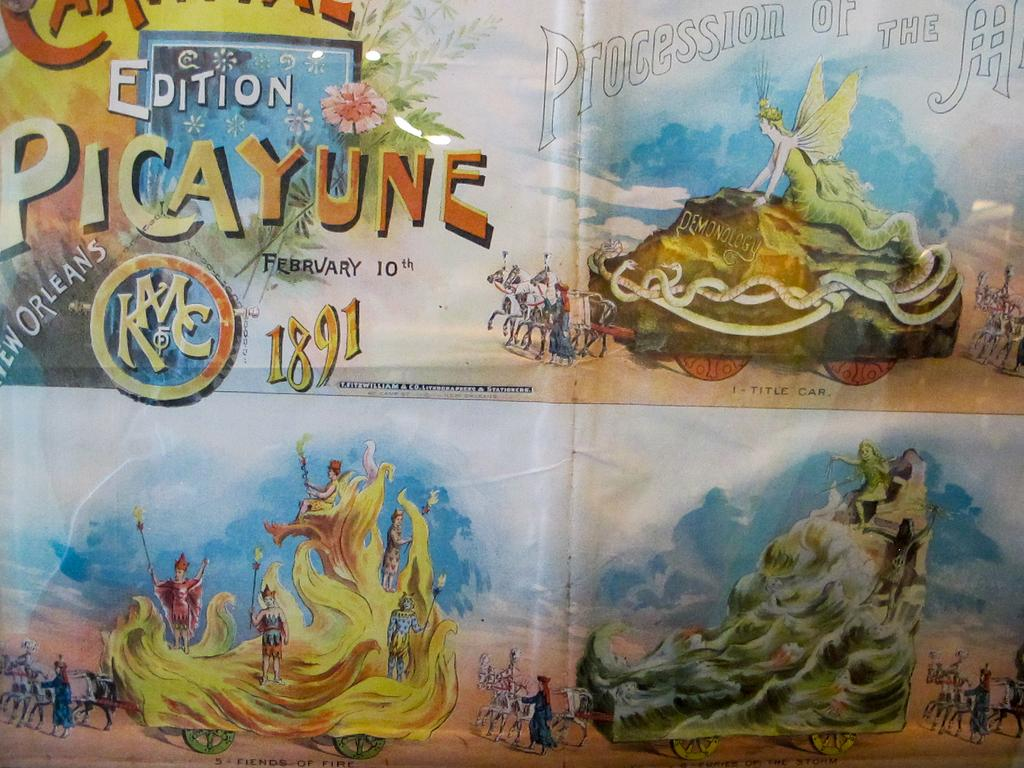What is present on the poster in the image? There is a poster in the image. What types of images are featured on the poster? The poster contains depictions of persons and vehicles. Is there any text present on the poster? Yes, the poster contains some text. How many baby sisters does the person depicted on the poster have? There is no information about the number of baby sisters for the person depicted on the poster, as the image only provides information about the poster's content. Is the partner of the person depicted on the poster also present in the image? There is no mention of a partner for the person depicted on the poster, nor is there any indication of their presence in the image. 